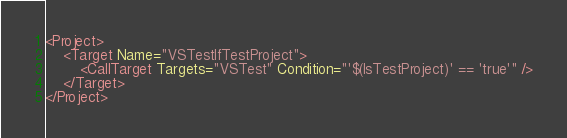Convert code to text. <code><loc_0><loc_0><loc_500><loc_500><_XML_><Project>
    <Target Name="VSTestIfTestProject">
        <CallTarget Targets="VSTest" Condition="'$(IsTestProject)' == 'true'" />
    </Target>
</Project></code> 